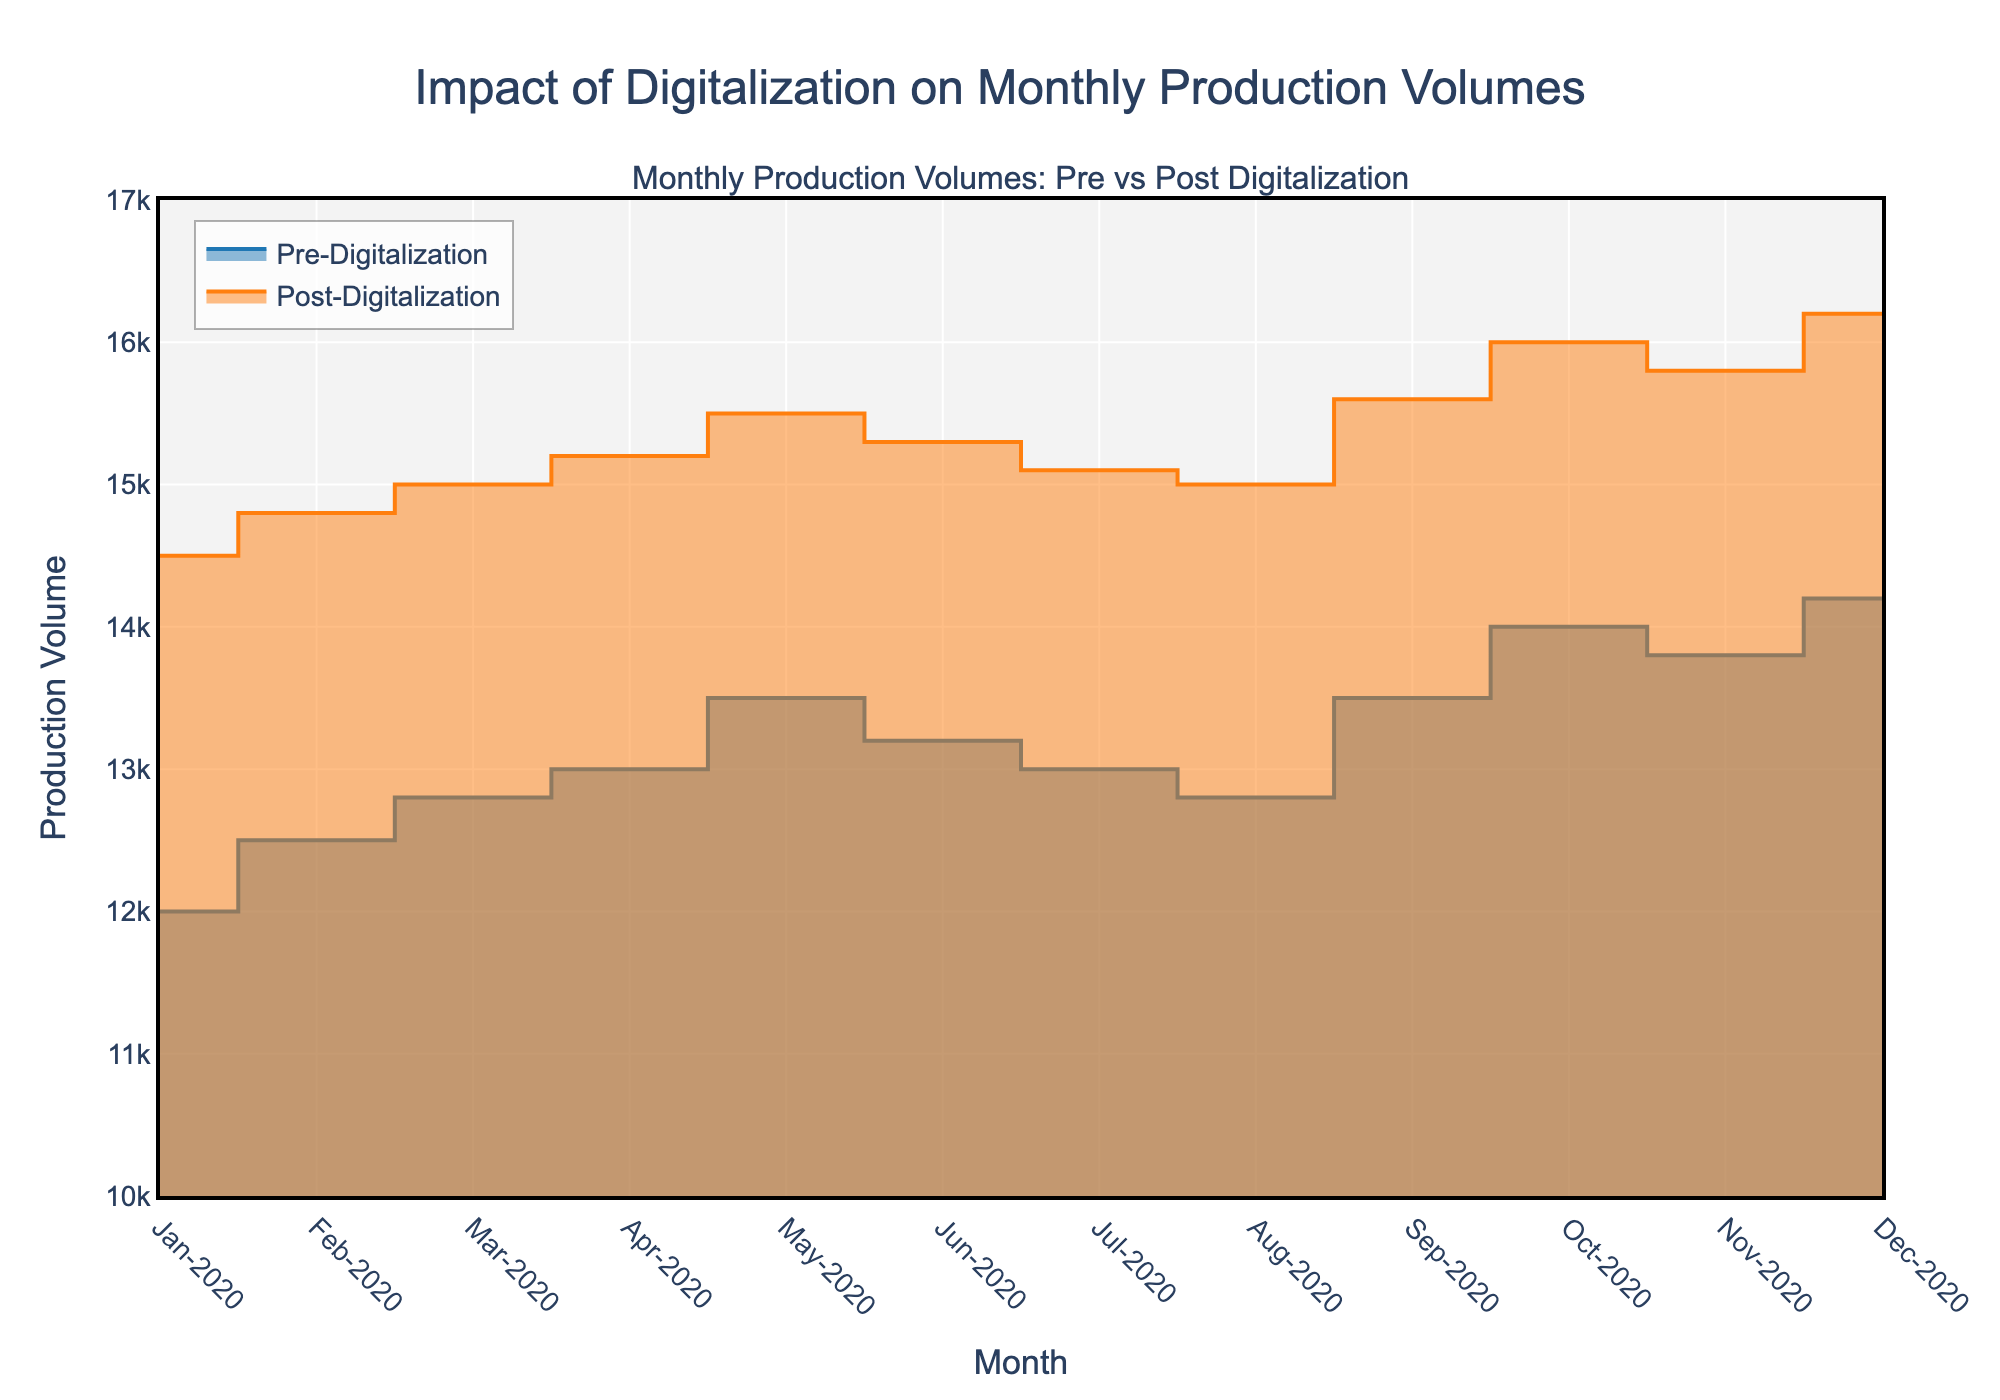How many months are shown on the x-axis? The x-axis is labeled with months from Jan-2020 to Dec-2020, totaling 12 months.
Answer: 12 What is the title of the chart? The title displayed at the top center of the chart is "Impact of Digitalization on Monthly Production Volumes."
Answer: "Impact of Digitalization on Monthly Production Volumes" Which month has the highest production volume post-digitalization? Searching through the post-digitalization data reveals that the highest production volume is 16200 units in Dec-2020.
Answer: Dec-2020 How much did production increase between pre-digitalization and post-digitalization in May-2020? The production volume pre-digitalization in May-2020 was 13500 units, and post-digitalization was 15500 units. The increase is 15500 - 13500 = 2000 units.
Answer: 2000 What is the difference in production volume between the highest and the lowest month post-digitalization? The highest production month post-digitalization is Dec-2020 with 16200 units, and the lowest is Jan-2020 with 14500 units. The difference is 16200 - 14500 = 1700 units.
Answer: 1700 Which months show a decline in production from one month to the next pre-digitalization? Comparing pre-digitalization data month by month, the declines are from May-2020 (13500) to Jun-2020 (13200) and from Jun-2020 (13200) to Jul-2020 (13000).
Answer: Jun-2020, Jul-2020 By how much did the production volume increase from Jan-2020 to Dec-2020 post-digitalization? The production volume in Jan-2020 was 14500 units and in Dec-2020 was 16200 units. The increase is 16200 - 14500 = 1700 units.
Answer: 1700 Which month has the smallest difference between pre-digitalization and post-digitalization production volumes? Calculating the differences for each month, the smallest difference is in Jan-2020 with 14500 - 12000 = 2500 units.
Answer: Jan-2020 Is there any month where the production volume was higher pre-digitalization compared to post-digitalization? Reviewing the data, there is no month where pre-digitalization production volume was higher than post-digitalization volume.
Answer: No What is the average monthly production volume post-digitalization for the entire year? Summing the post-digitalization volumes (14500 + 14800 + 15000 + 15200 + 15500 + 15300 + 15100 + 15000 + 15600 + 16000 + 15800 + 16200 = 178800), then dividing by 12 months gives 178800 / 12 = 14900 units.
Answer: 14900 